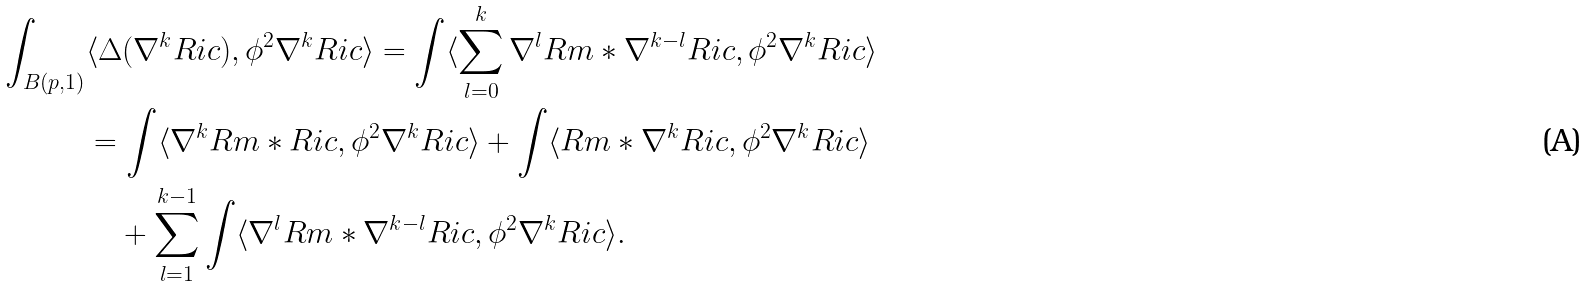<formula> <loc_0><loc_0><loc_500><loc_500>\int _ { B ( p , 1 ) } & \langle \Delta ( \nabla ^ { k } R i c ) , \phi ^ { 2 } \nabla ^ { k } R i c \rangle = \int \langle \sum _ { l = 0 } ^ { k } \nabla ^ { l } R m * \nabla ^ { k - l } R i c , \phi ^ { 2 } \nabla ^ { k } R i c \rangle \\ & = \int \langle \nabla ^ { k } R m * R i c , \phi ^ { 2 } \nabla ^ { k } R i c \rangle + \int \langle R m * \nabla ^ { k } R i c , \phi ^ { 2 } \nabla ^ { k } R i c \rangle \\ & \quad + \sum _ { l = 1 } ^ { k - 1 } \int \langle \nabla ^ { l } R m * \nabla ^ { k - l } R i c , \phi ^ { 2 } \nabla ^ { k } R i c \rangle .</formula> 